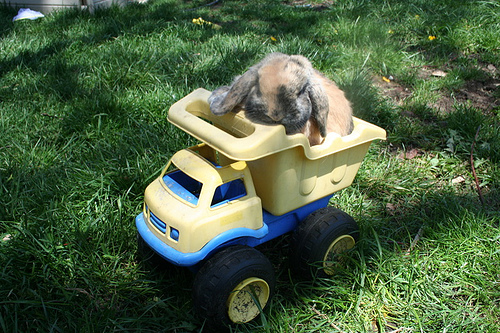<image>
Is there a dog on the truck? Yes. Looking at the image, I can see the dog is positioned on top of the truck, with the truck providing support. Where is the bunny in relation to the toy truck? Is it on the toy truck? Yes. Looking at the image, I can see the bunny is positioned on top of the toy truck, with the toy truck providing support. 